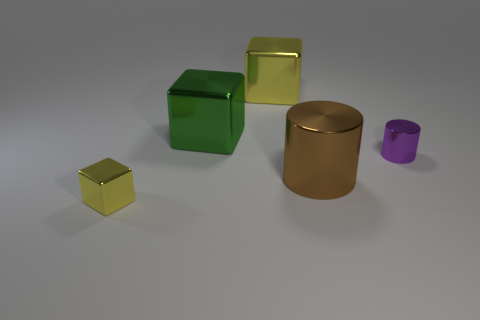Subtract all green cubes. How many cubes are left? 2 Subtract all cubes. How many objects are left? 2 Subtract all big things. Subtract all tiny yellow things. How many objects are left? 1 Add 2 big cubes. How many big cubes are left? 4 Add 1 green metallic things. How many green metallic things exist? 2 Add 2 brown shiny things. How many objects exist? 7 Subtract all green blocks. How many blocks are left? 2 Subtract 0 purple blocks. How many objects are left? 5 Subtract 2 cylinders. How many cylinders are left? 0 Subtract all red cylinders. Subtract all gray balls. How many cylinders are left? 2 